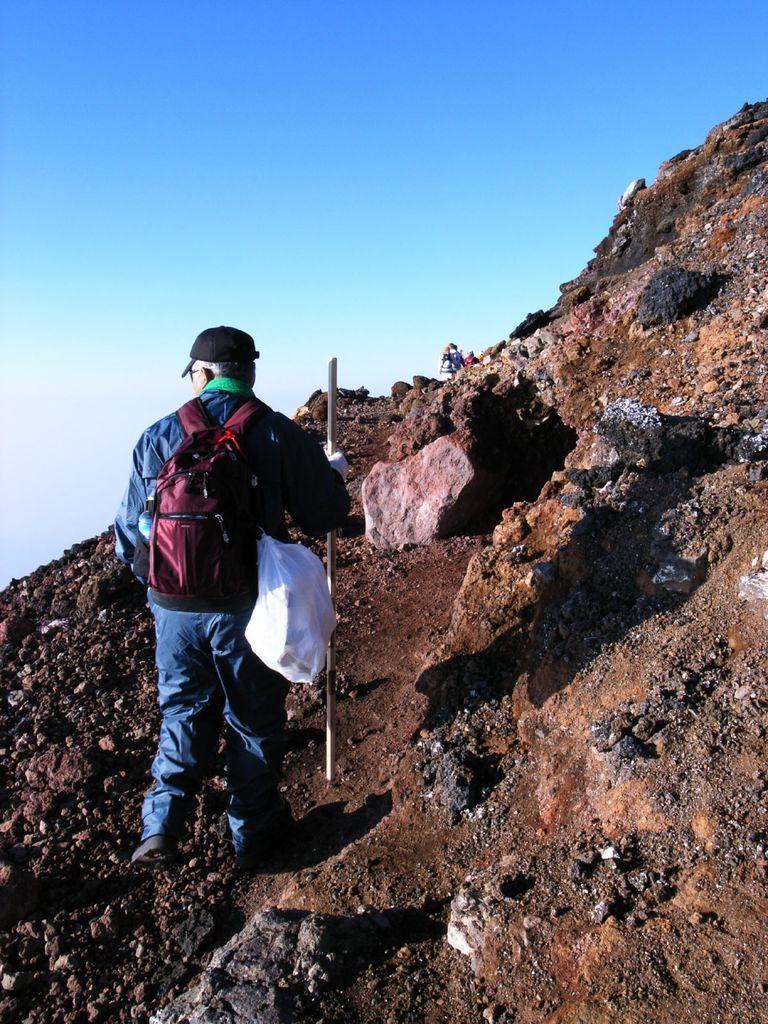Please provide a concise description of this image. A man is climbing mountain using a stick and carrying bags on his shoulder. In the background there are few people and sky. 